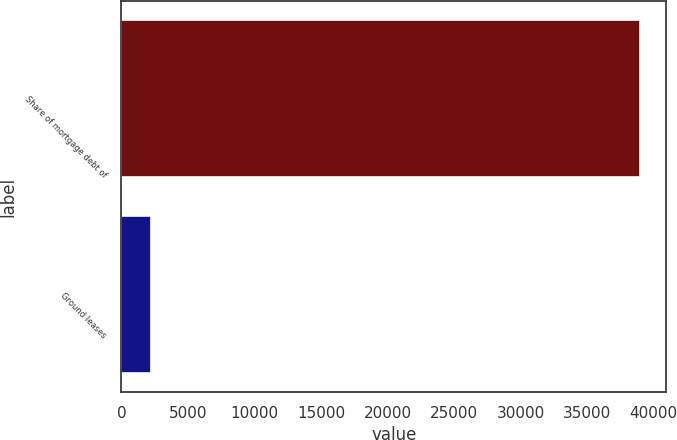Convert chart to OTSL. <chart><loc_0><loc_0><loc_500><loc_500><bar_chart><fcel>Share of mortgage debt of<fcel>Ground leases<nl><fcel>38986<fcel>2229<nl></chart> 